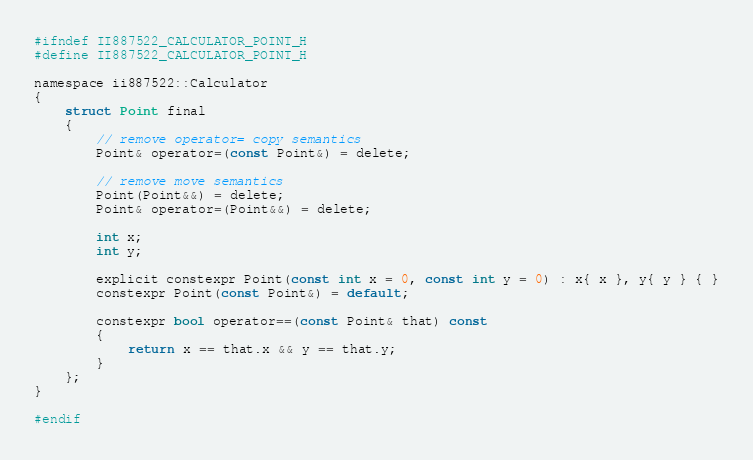<code> <loc_0><loc_0><loc_500><loc_500><_C_>#ifndef II887522_CALCULATOR_POINT_H
#define II887522_CALCULATOR_POINT_H

namespace ii887522::Calculator
{
	struct Point final
	{
		// remove operator= copy semantics
		Point& operator=(const Point&) = delete;

		// remove move semantics
		Point(Point&&) = delete;
		Point& operator=(Point&&) = delete;

		int x;
		int y;

		explicit constexpr Point(const int x = 0, const int y = 0) : x{ x }, y{ y } { }
		constexpr Point(const Point&) = default;

		constexpr bool operator==(const Point& that) const
		{
			return x == that.x && y == that.y;
		}
	};
}

#endif</code> 